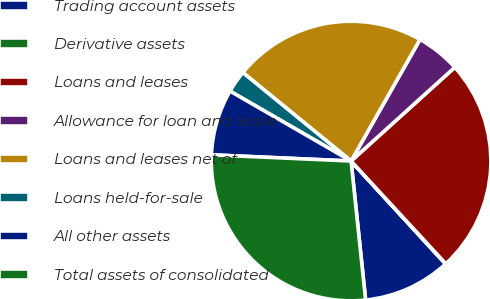Convert chart. <chart><loc_0><loc_0><loc_500><loc_500><pie_chart><fcel>Trading account assets<fcel>Derivative assets<fcel>Loans and leases<fcel>Allowance for loan and lease<fcel>Loans and leases net of<fcel>Loans held-for-sale<fcel>All other assets<fcel>Total assets of consolidated<nl><fcel>10.16%<fcel>0.04%<fcel>24.83%<fcel>5.1%<fcel>22.3%<fcel>2.57%<fcel>7.63%<fcel>27.36%<nl></chart> 